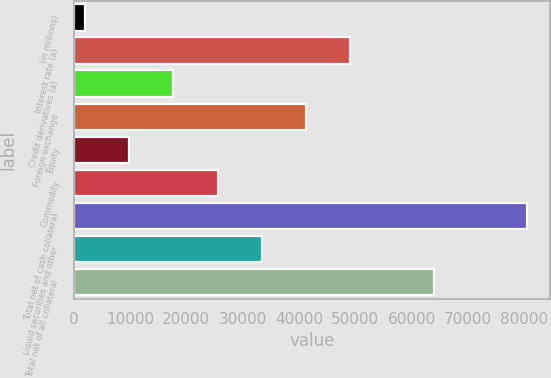Convert chart to OTSL. <chart><loc_0><loc_0><loc_500><loc_500><bar_chart><fcel>(in millions)<fcel>Interest rate (a)<fcel>Credit derivatives (a)<fcel>Foreign exchange<fcel>Equity<fcel>Commodity<fcel>Total net of cash collateral<fcel>Liquid securities and other<fcel>Total net of all collateral<nl><fcel>2010<fcel>49092.6<fcel>17704.2<fcel>41245.5<fcel>9857.1<fcel>25551.3<fcel>80481<fcel>33398.4<fcel>63995<nl></chart> 